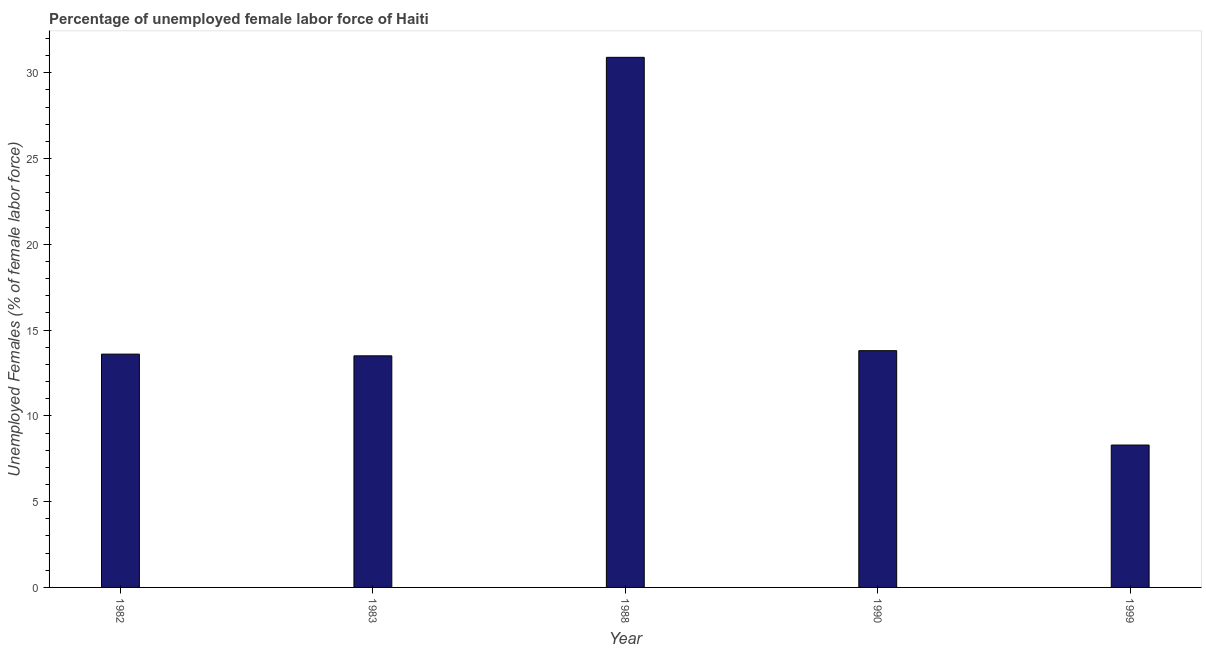Does the graph contain grids?
Provide a succinct answer. No. What is the title of the graph?
Your answer should be compact. Percentage of unemployed female labor force of Haiti. What is the label or title of the X-axis?
Your response must be concise. Year. What is the label or title of the Y-axis?
Offer a very short reply. Unemployed Females (% of female labor force). Across all years, what is the maximum total unemployed female labour force?
Your answer should be compact. 30.9. Across all years, what is the minimum total unemployed female labour force?
Make the answer very short. 8.3. What is the sum of the total unemployed female labour force?
Offer a very short reply. 80.1. What is the average total unemployed female labour force per year?
Your answer should be very brief. 16.02. What is the median total unemployed female labour force?
Offer a terse response. 13.6. In how many years, is the total unemployed female labour force greater than 6 %?
Provide a succinct answer. 5. Do a majority of the years between 1990 and 1982 (inclusive) have total unemployed female labour force greater than 3 %?
Your answer should be very brief. Yes. What is the ratio of the total unemployed female labour force in 1982 to that in 1988?
Provide a succinct answer. 0.44. Is the difference between the total unemployed female labour force in 1982 and 1990 greater than the difference between any two years?
Make the answer very short. No. What is the difference between the highest and the second highest total unemployed female labour force?
Ensure brevity in your answer.  17.1. What is the difference between the highest and the lowest total unemployed female labour force?
Provide a short and direct response. 22.6. In how many years, is the total unemployed female labour force greater than the average total unemployed female labour force taken over all years?
Your answer should be compact. 1. How many bars are there?
Provide a succinct answer. 5. Are the values on the major ticks of Y-axis written in scientific E-notation?
Your response must be concise. No. What is the Unemployed Females (% of female labor force) in 1982?
Provide a succinct answer. 13.6. What is the Unemployed Females (% of female labor force) of 1983?
Keep it short and to the point. 13.5. What is the Unemployed Females (% of female labor force) in 1988?
Give a very brief answer. 30.9. What is the Unemployed Females (% of female labor force) in 1990?
Your answer should be compact. 13.8. What is the Unemployed Females (% of female labor force) of 1999?
Offer a very short reply. 8.3. What is the difference between the Unemployed Females (% of female labor force) in 1982 and 1988?
Offer a terse response. -17.3. What is the difference between the Unemployed Females (% of female labor force) in 1982 and 1990?
Offer a very short reply. -0.2. What is the difference between the Unemployed Females (% of female labor force) in 1982 and 1999?
Offer a very short reply. 5.3. What is the difference between the Unemployed Females (% of female labor force) in 1983 and 1988?
Ensure brevity in your answer.  -17.4. What is the difference between the Unemployed Females (% of female labor force) in 1983 and 1990?
Keep it short and to the point. -0.3. What is the difference between the Unemployed Females (% of female labor force) in 1983 and 1999?
Give a very brief answer. 5.2. What is the difference between the Unemployed Females (% of female labor force) in 1988 and 1990?
Ensure brevity in your answer.  17.1. What is the difference between the Unemployed Females (% of female labor force) in 1988 and 1999?
Keep it short and to the point. 22.6. What is the ratio of the Unemployed Females (% of female labor force) in 1982 to that in 1988?
Keep it short and to the point. 0.44. What is the ratio of the Unemployed Females (% of female labor force) in 1982 to that in 1990?
Offer a terse response. 0.99. What is the ratio of the Unemployed Females (% of female labor force) in 1982 to that in 1999?
Provide a short and direct response. 1.64. What is the ratio of the Unemployed Females (% of female labor force) in 1983 to that in 1988?
Provide a succinct answer. 0.44. What is the ratio of the Unemployed Females (% of female labor force) in 1983 to that in 1990?
Offer a very short reply. 0.98. What is the ratio of the Unemployed Females (% of female labor force) in 1983 to that in 1999?
Make the answer very short. 1.63. What is the ratio of the Unemployed Females (% of female labor force) in 1988 to that in 1990?
Offer a terse response. 2.24. What is the ratio of the Unemployed Females (% of female labor force) in 1988 to that in 1999?
Provide a short and direct response. 3.72. What is the ratio of the Unemployed Females (% of female labor force) in 1990 to that in 1999?
Your response must be concise. 1.66. 